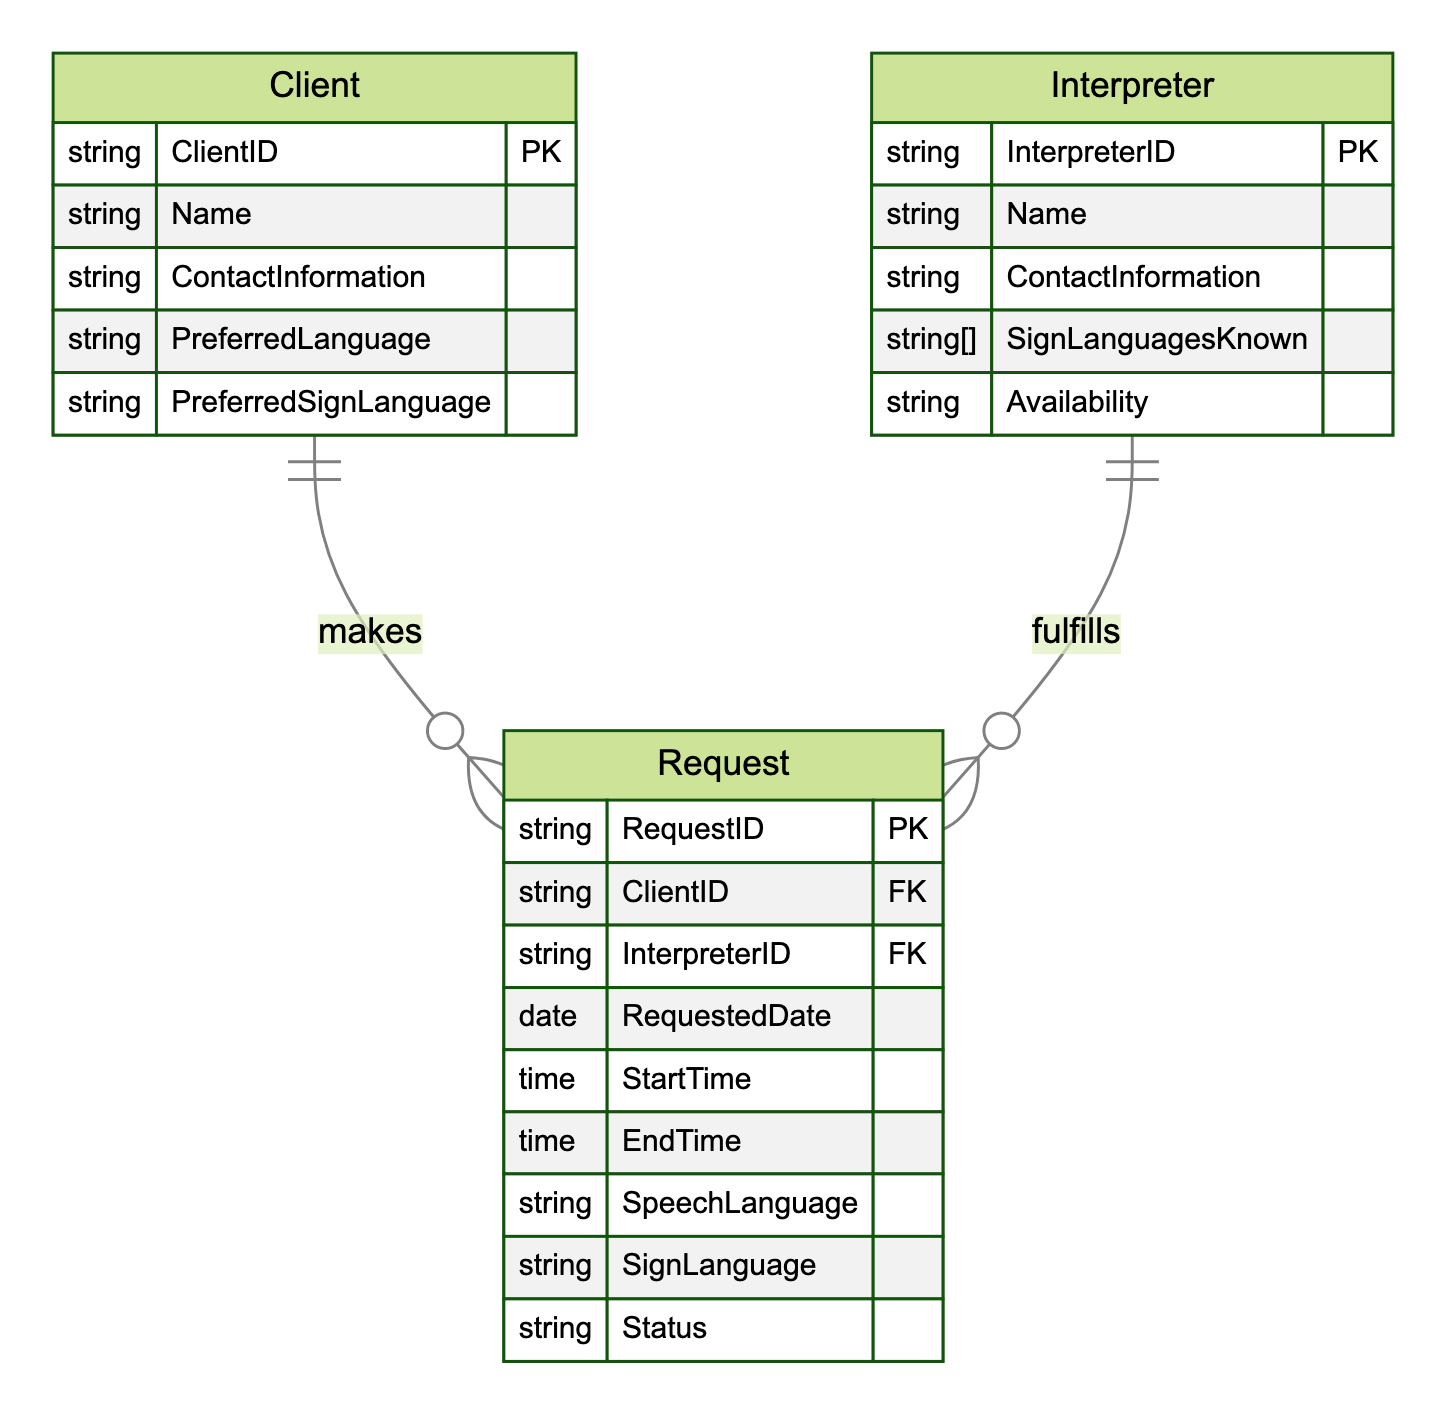What entities are present in the diagram? The diagram contains three entities: Client, Interpreter, and Request. Each entity is represented as a rectangle in the ER diagram.
Answer: Client, Interpreter, Request How many attributes does the Interpreter entity have? The Interpreter entity has five attributes: InterpreterID, Name, ContactInformation, SignLanguagesKnown, and Availability. The count of these attributes can be obtained by enumerating the list in the entity definition.
Answer: 5 What is the primary key of the Request entity? The primary key of the Request entity is RequestID. The diagram designates primary keys often with "PK" in the context of entities listed in the diagram.
Answer: RequestID How many Sign Languages are known by an Interpreter? The number of Sign Languages known by an Interpreter could vary since the entity lists SignLanguagesKnown as an attribute indicative of an array. This implies multiple languages can be associated with one interpreter.
Answer: multiple Which entity can initiate a Request? The Client entity can initiate a Request, as shown by the relationship where the Client makes one or more Requests. In the ER diagram, this initiator is always positioned on the "one" side of the "one-to-many" relationship symbol.
Answer: Client Can an Interpreter fulfill multiple Requests? Yes, an Interpreter can fulfill multiple Requests, as indicated by the one-to-many relationship defined between the Interpreter and Request entities in the diagram. This means each interpreter can be assigned to several requests over time.
Answer: Yes What attribute indicates if an Interpreter is available? The attribute that indicates if an Interpreter is available is Availability. This attribute can provide information on whether an interpreter can take on new requests at a given time based on the entity's designation.
Answer: Availability What status might be assigned to a Request? The Status attribute in the Request entity can be used to indicate various states such as "Pending," "Completed," or "Cancelled." This attribute defines the current state of each request in the system.
Answer: Status 